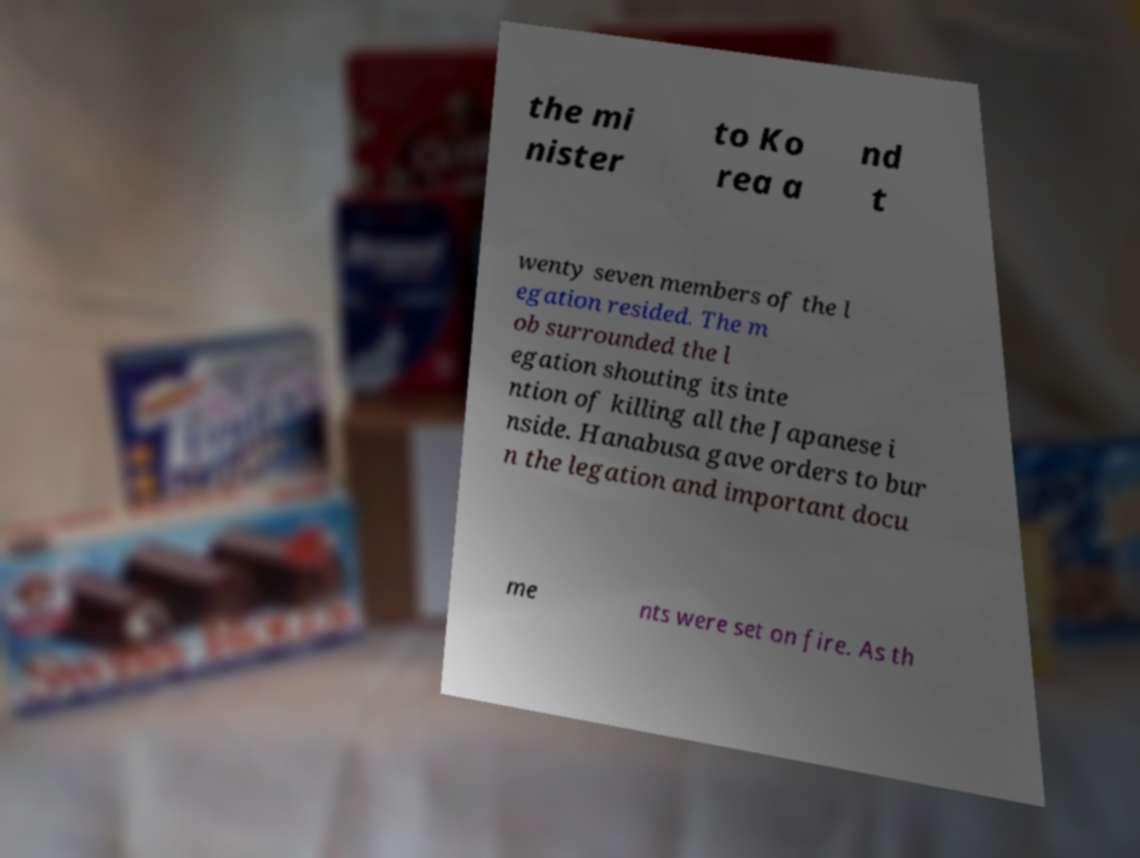Could you extract and type out the text from this image? the mi nister to Ko rea a nd t wenty seven members of the l egation resided. The m ob surrounded the l egation shouting its inte ntion of killing all the Japanese i nside. Hanabusa gave orders to bur n the legation and important docu me nts were set on fire. As th 